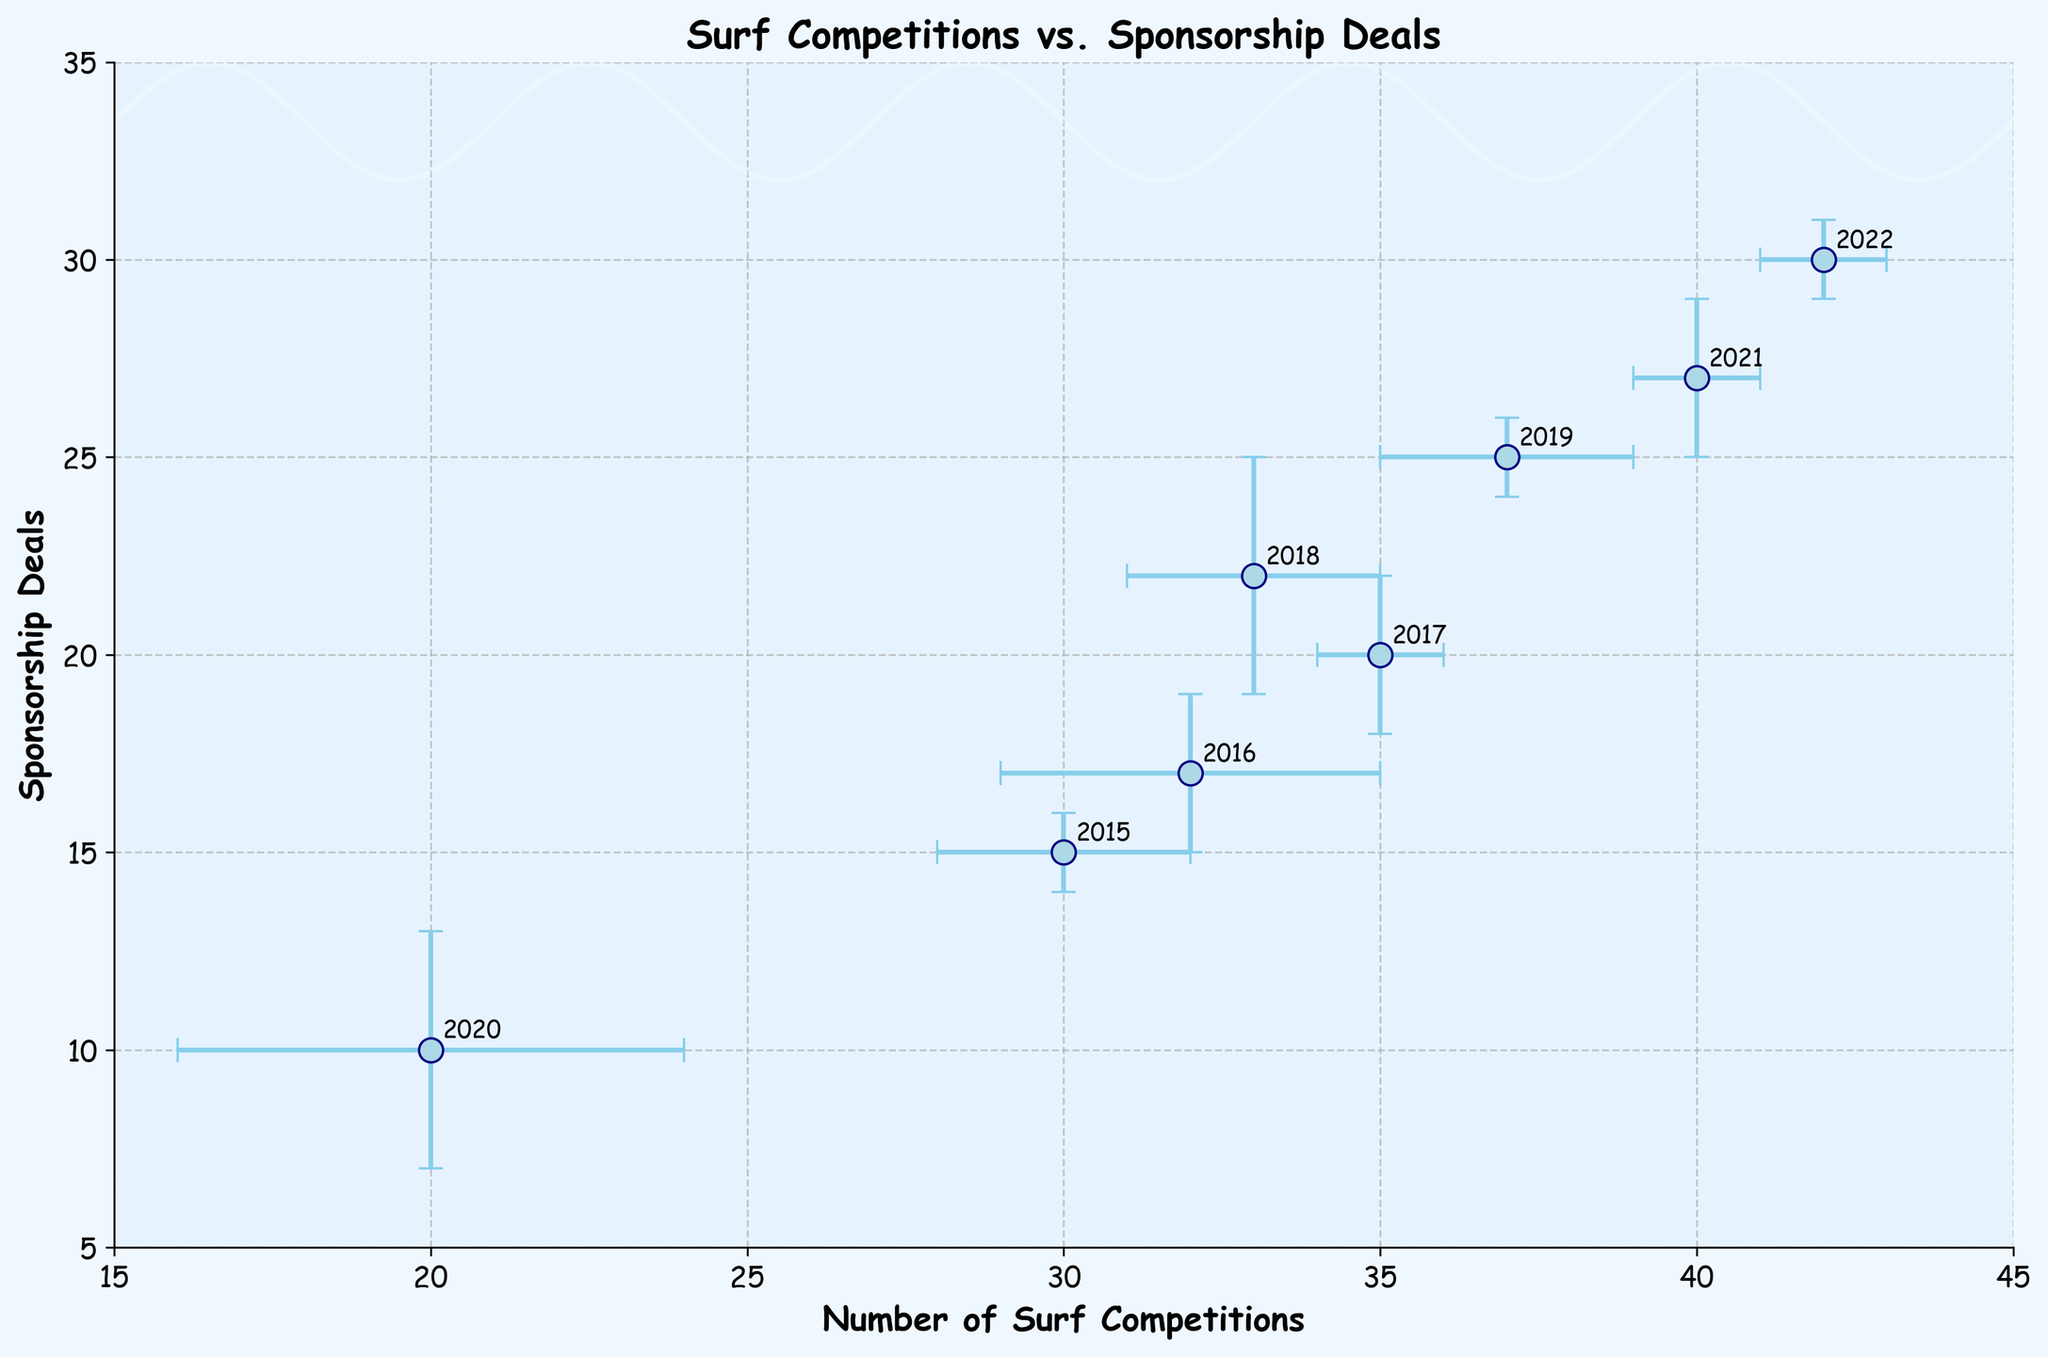What's the title of the figure? The title is usually found at the top center of the figure, and it gives an overview of what the plot is about. In this plot, the title is clearly stated at the top.
Answer: Surf Competitions vs. Sponsorship Deals How many years of data are represented in the plot? Each data point corresponds to a specific year, and there are labels beside the points indicating the years. Counting these labels will give us the total number of years represented.
Answer: 8 What is the range of the number of surf competitions depicted in the plot? The x-axis represents the number of surf competitions, and the range can be determined by looking at the smallest and largest x-values.
Answer: 20 to 42 Which year had the lowest number of surf competitions? By checking the x-values associated with each annotated year, we identify the year with the smallest x-value.
Answer: 2020 What is the average number of sponsorship deals over the given years? To find the average, sum up the sponsorship deals for each year and divide by the number of years. Calculation: (15 + 17 + 20 + 22 + 25 + 10 + 27 + 30) / 8 = 20.75
Answer: 20.75 How do the error bars for the number of competitions compare to those for the deals in 2018? Locate the point for 2018 and visually compare the length of the horizontal and vertical error bars.
Answer: The error bar for competitions is smaller Which year had the highest sponsorship deals, and how many were there? Identify the year with the highest y-value, indicating the number of sponsorship deals. Look for the label of that year.
Answer: 2022 with 30 deals Was there an increase or decrease in the number of surf competitions between 2019 and 2020? Compare the x-value for 2019 with that for 2020. A decrease would indicate the x-value for 2020 is less.
Answer: Decrease What is the trend in the number of sponsorship deals from 2015 to 2022? Observe the y-values over the given time period. An overall increase in y-values indicates an increasing trend.
Answer: Increasing trend Compare the error bars for sponsorship deals in 2016 and 2017. Which year had a larger uncertainty? Check the vertical error bars for both years and compare their lengths.
Answer: 2016 had a larger uncertainty 